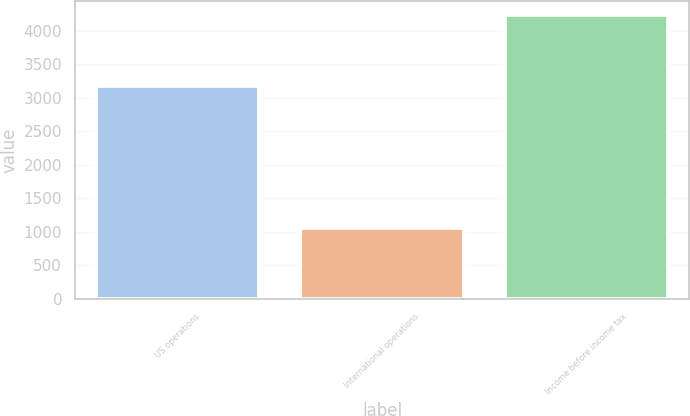<chart> <loc_0><loc_0><loc_500><loc_500><bar_chart><fcel>US operations<fcel>International operations<fcel>Income before income tax<nl><fcel>3168<fcel>1064<fcel>4232<nl></chart> 